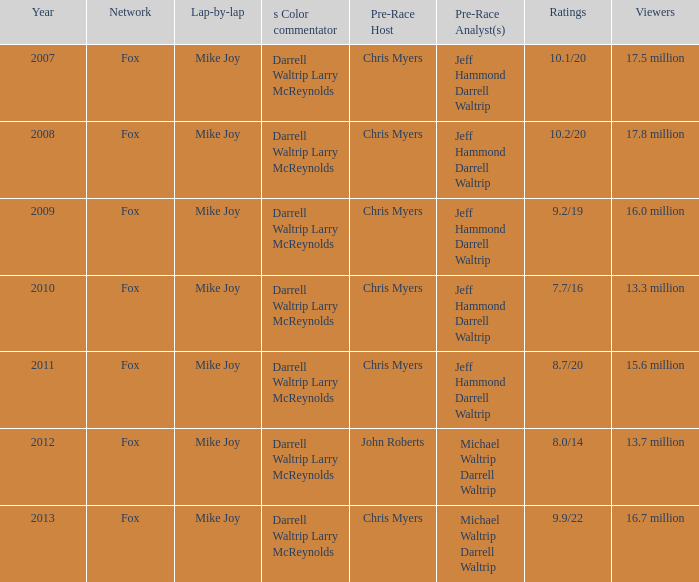Which broadcasting network has an audience of 17.5 million individuals? Fox. 